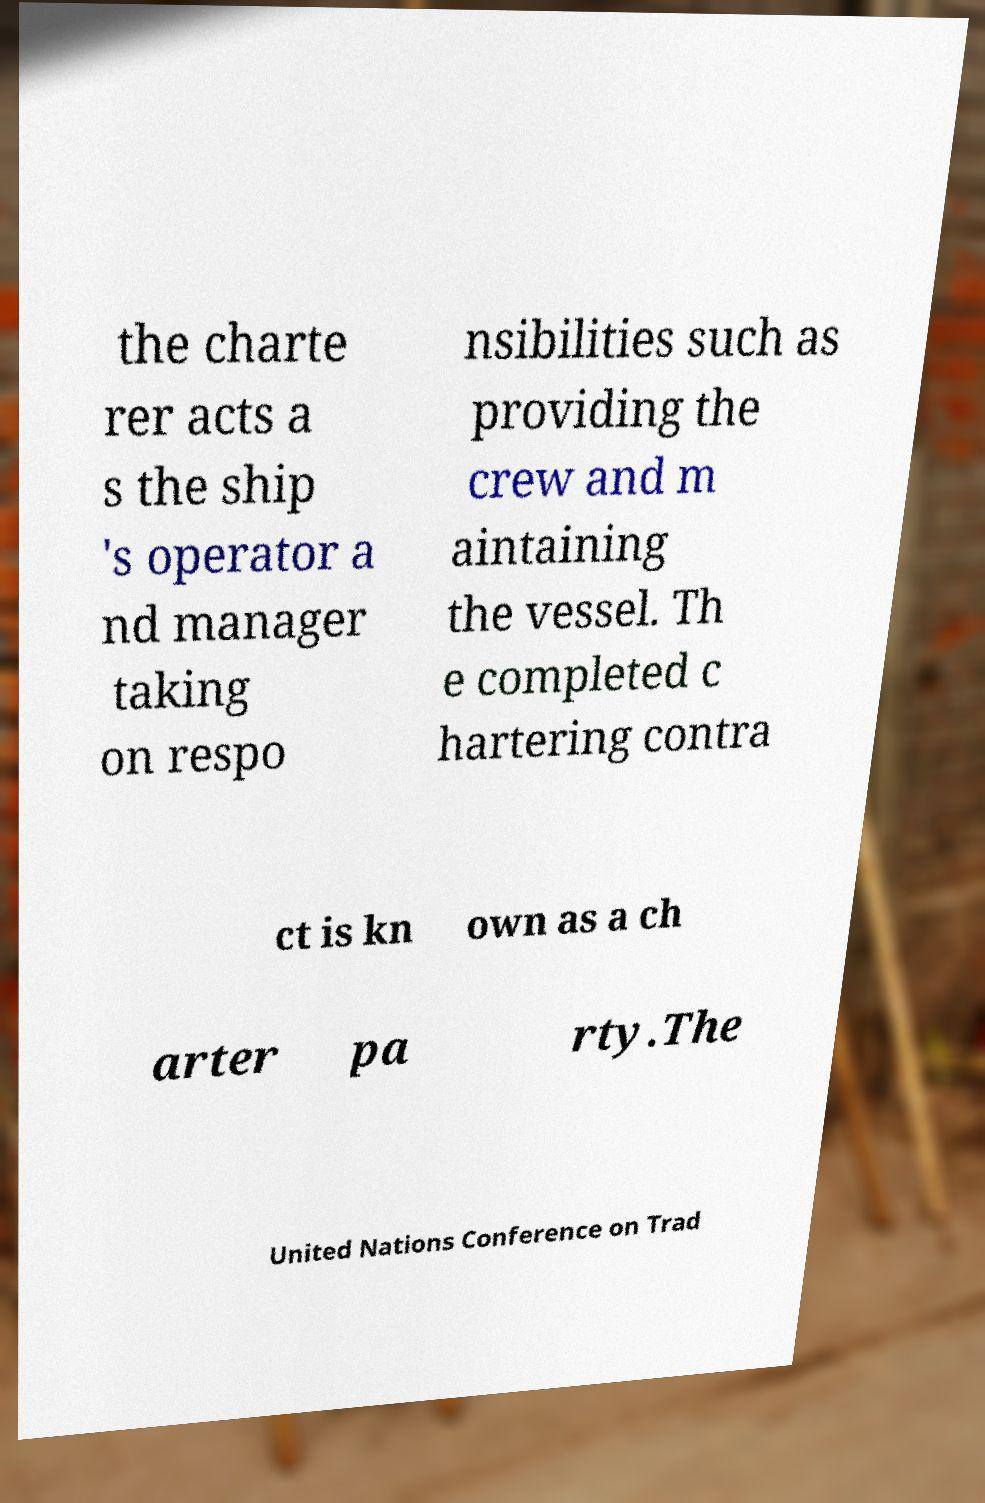There's text embedded in this image that I need extracted. Can you transcribe it verbatim? the charte rer acts a s the ship 's operator a nd manager taking on respo nsibilities such as providing the crew and m aintaining the vessel. Th e completed c hartering contra ct is kn own as a ch arter pa rty.The United Nations Conference on Trad 